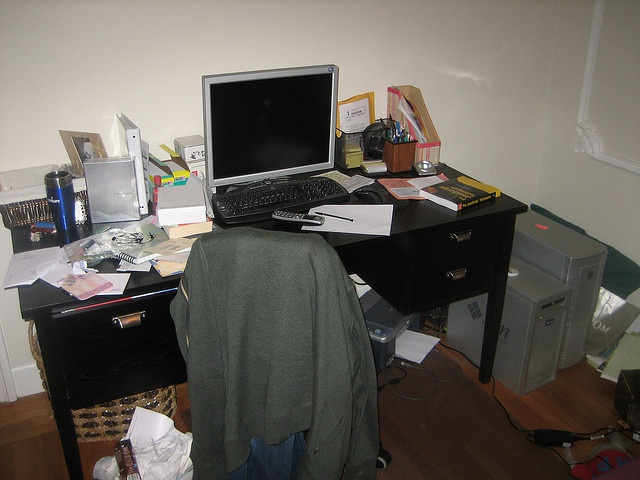Describe the objects in this image and their specific colors. I can see chair in gray and black tones, tv in gray, black, darkgray, and lightgray tones, keyboard in gray and black tones, book in gray, black, and darkgray tones, and book in gray, darkgray, white, and lightgray tones in this image. 